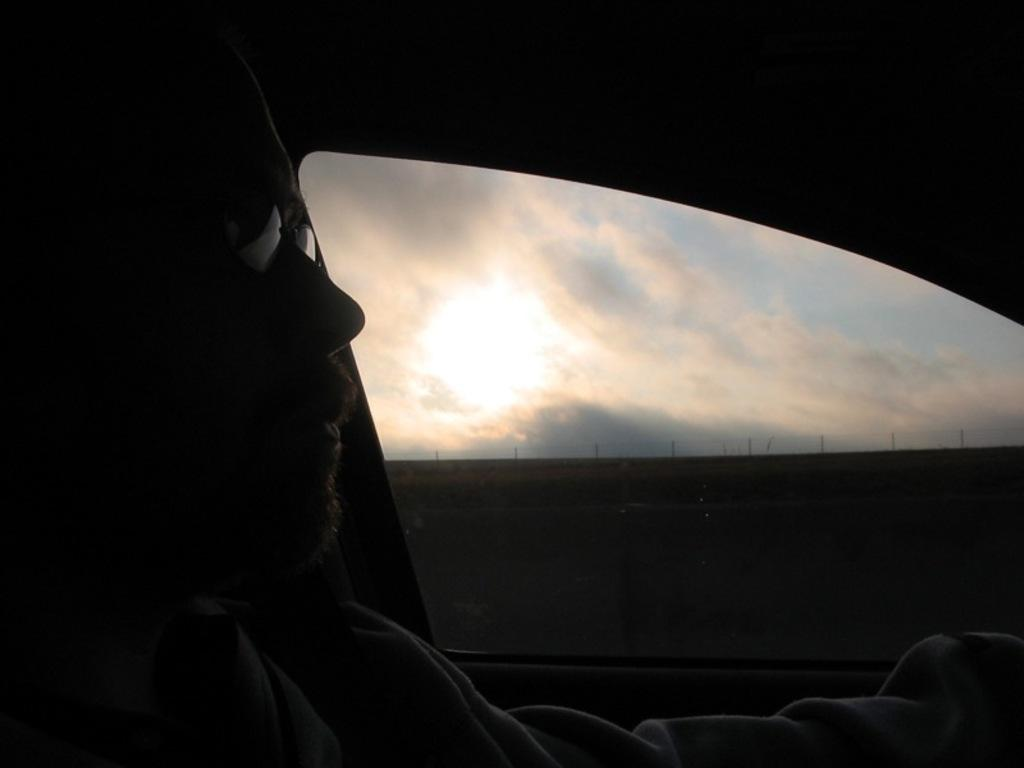Who is present in the image? There is a man in the image. What is the man wearing on his face? The man is wearing goggles. What type of clothing is the man wearing on his upper body? The man is wearing a shirt. Where is the man located in the image? The man is sitting inside a car. What can be seen through the car window? Fencing, a wall partition, the sky, clouds, and the sun can be seen through the car window. What type of crib is visible through the car window? There is no crib visible through the car window; the image only shows fencing, a wall partition, the sky, clouds, and the sun. What kind of beast is sitting next to the man in the car? There is no beast present in the image; only the man is visible inside the car. 